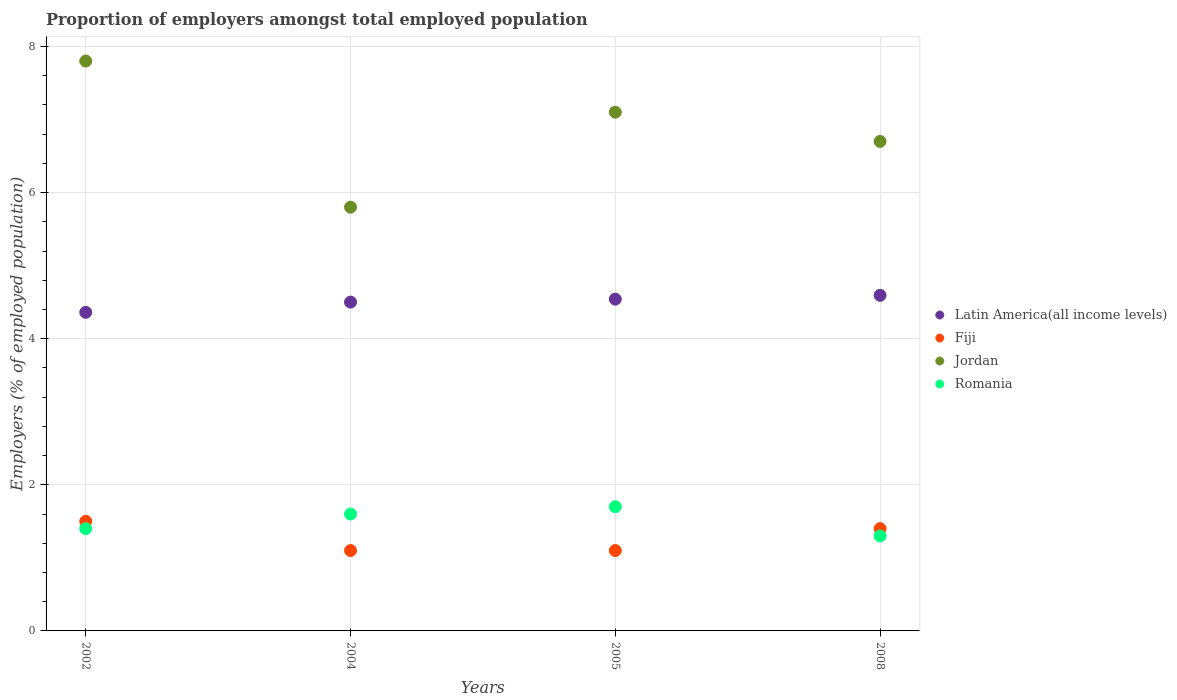What is the proportion of employers in Latin America(all income levels) in 2008?
Provide a short and direct response. 4.59. Across all years, what is the maximum proportion of employers in Romania?
Keep it short and to the point. 1.7. Across all years, what is the minimum proportion of employers in Romania?
Your answer should be compact. 1.3. In which year was the proportion of employers in Romania minimum?
Your answer should be compact. 2008. What is the total proportion of employers in Latin America(all income levels) in the graph?
Offer a terse response. 18. What is the difference between the proportion of employers in Latin America(all income levels) in 2004 and that in 2008?
Offer a very short reply. -0.09. What is the difference between the proportion of employers in Latin America(all income levels) in 2004 and the proportion of employers in Romania in 2005?
Your answer should be compact. 2.8. What is the average proportion of employers in Fiji per year?
Your response must be concise. 1.28. In the year 2002, what is the difference between the proportion of employers in Fiji and proportion of employers in Romania?
Provide a short and direct response. 0.1. In how many years, is the proportion of employers in Romania greater than 2 %?
Give a very brief answer. 0. What is the ratio of the proportion of employers in Latin America(all income levels) in 2002 to that in 2005?
Offer a terse response. 0.96. Is the difference between the proportion of employers in Fiji in 2002 and 2008 greater than the difference between the proportion of employers in Romania in 2002 and 2008?
Provide a succinct answer. No. What is the difference between the highest and the second highest proportion of employers in Latin America(all income levels)?
Keep it short and to the point. 0.05. What is the difference between the highest and the lowest proportion of employers in Jordan?
Keep it short and to the point. 2. Is it the case that in every year, the sum of the proportion of employers in Jordan and proportion of employers in Romania  is greater than the sum of proportion of employers in Latin America(all income levels) and proportion of employers in Fiji?
Your response must be concise. Yes. Does the proportion of employers in Latin America(all income levels) monotonically increase over the years?
Your answer should be compact. Yes. How many dotlines are there?
Make the answer very short. 4. Are the values on the major ticks of Y-axis written in scientific E-notation?
Provide a short and direct response. No. Where does the legend appear in the graph?
Give a very brief answer. Center right. How are the legend labels stacked?
Ensure brevity in your answer.  Vertical. What is the title of the graph?
Offer a very short reply. Proportion of employers amongst total employed population. Does "Suriname" appear as one of the legend labels in the graph?
Provide a short and direct response. No. What is the label or title of the X-axis?
Ensure brevity in your answer.  Years. What is the label or title of the Y-axis?
Your response must be concise. Employers (% of employed population). What is the Employers (% of employed population) of Latin America(all income levels) in 2002?
Provide a short and direct response. 4.36. What is the Employers (% of employed population) in Jordan in 2002?
Offer a very short reply. 7.8. What is the Employers (% of employed population) in Romania in 2002?
Provide a short and direct response. 1.4. What is the Employers (% of employed population) of Latin America(all income levels) in 2004?
Offer a very short reply. 4.5. What is the Employers (% of employed population) in Fiji in 2004?
Offer a terse response. 1.1. What is the Employers (% of employed population) of Jordan in 2004?
Your answer should be compact. 5.8. What is the Employers (% of employed population) in Romania in 2004?
Ensure brevity in your answer.  1.6. What is the Employers (% of employed population) in Latin America(all income levels) in 2005?
Provide a succinct answer. 4.54. What is the Employers (% of employed population) of Fiji in 2005?
Keep it short and to the point. 1.1. What is the Employers (% of employed population) in Jordan in 2005?
Provide a short and direct response. 7.1. What is the Employers (% of employed population) of Romania in 2005?
Ensure brevity in your answer.  1.7. What is the Employers (% of employed population) of Latin America(all income levels) in 2008?
Your response must be concise. 4.59. What is the Employers (% of employed population) in Fiji in 2008?
Offer a terse response. 1.4. What is the Employers (% of employed population) in Jordan in 2008?
Give a very brief answer. 6.7. What is the Employers (% of employed population) of Romania in 2008?
Offer a terse response. 1.3. Across all years, what is the maximum Employers (% of employed population) in Latin America(all income levels)?
Your answer should be compact. 4.59. Across all years, what is the maximum Employers (% of employed population) of Fiji?
Provide a succinct answer. 1.5. Across all years, what is the maximum Employers (% of employed population) of Jordan?
Make the answer very short. 7.8. Across all years, what is the maximum Employers (% of employed population) of Romania?
Provide a short and direct response. 1.7. Across all years, what is the minimum Employers (% of employed population) in Latin America(all income levels)?
Your answer should be compact. 4.36. Across all years, what is the minimum Employers (% of employed population) in Fiji?
Give a very brief answer. 1.1. Across all years, what is the minimum Employers (% of employed population) of Jordan?
Ensure brevity in your answer.  5.8. Across all years, what is the minimum Employers (% of employed population) of Romania?
Provide a short and direct response. 1.3. What is the total Employers (% of employed population) in Latin America(all income levels) in the graph?
Your response must be concise. 18. What is the total Employers (% of employed population) of Fiji in the graph?
Give a very brief answer. 5.1. What is the total Employers (% of employed population) in Jordan in the graph?
Make the answer very short. 27.4. What is the total Employers (% of employed population) in Romania in the graph?
Ensure brevity in your answer.  6. What is the difference between the Employers (% of employed population) of Latin America(all income levels) in 2002 and that in 2004?
Offer a terse response. -0.14. What is the difference between the Employers (% of employed population) of Fiji in 2002 and that in 2004?
Your answer should be compact. 0.4. What is the difference between the Employers (% of employed population) of Jordan in 2002 and that in 2004?
Your answer should be very brief. 2. What is the difference between the Employers (% of employed population) of Latin America(all income levels) in 2002 and that in 2005?
Keep it short and to the point. -0.18. What is the difference between the Employers (% of employed population) of Latin America(all income levels) in 2002 and that in 2008?
Your answer should be very brief. -0.23. What is the difference between the Employers (% of employed population) of Jordan in 2002 and that in 2008?
Make the answer very short. 1.1. What is the difference between the Employers (% of employed population) in Romania in 2002 and that in 2008?
Offer a very short reply. 0.1. What is the difference between the Employers (% of employed population) in Latin America(all income levels) in 2004 and that in 2005?
Make the answer very short. -0.04. What is the difference between the Employers (% of employed population) in Latin America(all income levels) in 2004 and that in 2008?
Your response must be concise. -0.09. What is the difference between the Employers (% of employed population) in Fiji in 2004 and that in 2008?
Your response must be concise. -0.3. What is the difference between the Employers (% of employed population) in Jordan in 2004 and that in 2008?
Your response must be concise. -0.9. What is the difference between the Employers (% of employed population) of Romania in 2004 and that in 2008?
Your response must be concise. 0.3. What is the difference between the Employers (% of employed population) of Latin America(all income levels) in 2005 and that in 2008?
Your answer should be very brief. -0.05. What is the difference between the Employers (% of employed population) in Jordan in 2005 and that in 2008?
Offer a terse response. 0.4. What is the difference between the Employers (% of employed population) of Romania in 2005 and that in 2008?
Your answer should be compact. 0.4. What is the difference between the Employers (% of employed population) in Latin America(all income levels) in 2002 and the Employers (% of employed population) in Fiji in 2004?
Keep it short and to the point. 3.26. What is the difference between the Employers (% of employed population) in Latin America(all income levels) in 2002 and the Employers (% of employed population) in Jordan in 2004?
Provide a succinct answer. -1.44. What is the difference between the Employers (% of employed population) of Latin America(all income levels) in 2002 and the Employers (% of employed population) of Romania in 2004?
Ensure brevity in your answer.  2.76. What is the difference between the Employers (% of employed population) in Fiji in 2002 and the Employers (% of employed population) in Jordan in 2004?
Ensure brevity in your answer.  -4.3. What is the difference between the Employers (% of employed population) in Fiji in 2002 and the Employers (% of employed population) in Romania in 2004?
Your answer should be compact. -0.1. What is the difference between the Employers (% of employed population) in Latin America(all income levels) in 2002 and the Employers (% of employed population) in Fiji in 2005?
Your answer should be compact. 3.26. What is the difference between the Employers (% of employed population) of Latin America(all income levels) in 2002 and the Employers (% of employed population) of Jordan in 2005?
Provide a short and direct response. -2.74. What is the difference between the Employers (% of employed population) of Latin America(all income levels) in 2002 and the Employers (% of employed population) of Romania in 2005?
Provide a short and direct response. 2.66. What is the difference between the Employers (% of employed population) of Fiji in 2002 and the Employers (% of employed population) of Romania in 2005?
Provide a succinct answer. -0.2. What is the difference between the Employers (% of employed population) in Jordan in 2002 and the Employers (% of employed population) in Romania in 2005?
Offer a very short reply. 6.1. What is the difference between the Employers (% of employed population) in Latin America(all income levels) in 2002 and the Employers (% of employed population) in Fiji in 2008?
Provide a succinct answer. 2.96. What is the difference between the Employers (% of employed population) in Latin America(all income levels) in 2002 and the Employers (% of employed population) in Jordan in 2008?
Ensure brevity in your answer.  -2.34. What is the difference between the Employers (% of employed population) in Latin America(all income levels) in 2002 and the Employers (% of employed population) in Romania in 2008?
Offer a terse response. 3.06. What is the difference between the Employers (% of employed population) in Fiji in 2002 and the Employers (% of employed population) in Romania in 2008?
Make the answer very short. 0.2. What is the difference between the Employers (% of employed population) in Latin America(all income levels) in 2004 and the Employers (% of employed population) in Fiji in 2005?
Give a very brief answer. 3.4. What is the difference between the Employers (% of employed population) of Latin America(all income levels) in 2004 and the Employers (% of employed population) of Jordan in 2005?
Give a very brief answer. -2.6. What is the difference between the Employers (% of employed population) in Latin America(all income levels) in 2004 and the Employers (% of employed population) in Romania in 2005?
Offer a very short reply. 2.8. What is the difference between the Employers (% of employed population) in Jordan in 2004 and the Employers (% of employed population) in Romania in 2005?
Make the answer very short. 4.1. What is the difference between the Employers (% of employed population) in Latin America(all income levels) in 2004 and the Employers (% of employed population) in Fiji in 2008?
Keep it short and to the point. 3.1. What is the difference between the Employers (% of employed population) of Latin America(all income levels) in 2004 and the Employers (% of employed population) of Jordan in 2008?
Ensure brevity in your answer.  -2.2. What is the difference between the Employers (% of employed population) in Latin America(all income levels) in 2004 and the Employers (% of employed population) in Romania in 2008?
Make the answer very short. 3.2. What is the difference between the Employers (% of employed population) in Fiji in 2004 and the Employers (% of employed population) in Jordan in 2008?
Make the answer very short. -5.6. What is the difference between the Employers (% of employed population) in Fiji in 2004 and the Employers (% of employed population) in Romania in 2008?
Provide a short and direct response. -0.2. What is the difference between the Employers (% of employed population) of Latin America(all income levels) in 2005 and the Employers (% of employed population) of Fiji in 2008?
Your response must be concise. 3.14. What is the difference between the Employers (% of employed population) of Latin America(all income levels) in 2005 and the Employers (% of employed population) of Jordan in 2008?
Give a very brief answer. -2.16. What is the difference between the Employers (% of employed population) of Latin America(all income levels) in 2005 and the Employers (% of employed population) of Romania in 2008?
Provide a succinct answer. 3.24. What is the difference between the Employers (% of employed population) in Fiji in 2005 and the Employers (% of employed population) in Jordan in 2008?
Provide a succinct answer. -5.6. What is the difference between the Employers (% of employed population) in Jordan in 2005 and the Employers (% of employed population) in Romania in 2008?
Offer a very short reply. 5.8. What is the average Employers (% of employed population) in Latin America(all income levels) per year?
Your answer should be compact. 4.5. What is the average Employers (% of employed population) in Fiji per year?
Make the answer very short. 1.27. What is the average Employers (% of employed population) of Jordan per year?
Offer a terse response. 6.85. What is the average Employers (% of employed population) in Romania per year?
Provide a succinct answer. 1.5. In the year 2002, what is the difference between the Employers (% of employed population) of Latin America(all income levels) and Employers (% of employed population) of Fiji?
Provide a succinct answer. 2.86. In the year 2002, what is the difference between the Employers (% of employed population) of Latin America(all income levels) and Employers (% of employed population) of Jordan?
Your response must be concise. -3.44. In the year 2002, what is the difference between the Employers (% of employed population) in Latin America(all income levels) and Employers (% of employed population) in Romania?
Your answer should be very brief. 2.96. In the year 2004, what is the difference between the Employers (% of employed population) in Latin America(all income levels) and Employers (% of employed population) in Fiji?
Give a very brief answer. 3.4. In the year 2004, what is the difference between the Employers (% of employed population) of Latin America(all income levels) and Employers (% of employed population) of Jordan?
Offer a terse response. -1.3. In the year 2004, what is the difference between the Employers (% of employed population) in Latin America(all income levels) and Employers (% of employed population) in Romania?
Offer a terse response. 2.9. In the year 2004, what is the difference between the Employers (% of employed population) in Fiji and Employers (% of employed population) in Jordan?
Your answer should be compact. -4.7. In the year 2004, what is the difference between the Employers (% of employed population) in Fiji and Employers (% of employed population) in Romania?
Keep it short and to the point. -0.5. In the year 2005, what is the difference between the Employers (% of employed population) in Latin America(all income levels) and Employers (% of employed population) in Fiji?
Your answer should be very brief. 3.44. In the year 2005, what is the difference between the Employers (% of employed population) in Latin America(all income levels) and Employers (% of employed population) in Jordan?
Your response must be concise. -2.56. In the year 2005, what is the difference between the Employers (% of employed population) in Latin America(all income levels) and Employers (% of employed population) in Romania?
Offer a very short reply. 2.84. In the year 2005, what is the difference between the Employers (% of employed population) in Jordan and Employers (% of employed population) in Romania?
Keep it short and to the point. 5.4. In the year 2008, what is the difference between the Employers (% of employed population) of Latin America(all income levels) and Employers (% of employed population) of Fiji?
Make the answer very short. 3.19. In the year 2008, what is the difference between the Employers (% of employed population) in Latin America(all income levels) and Employers (% of employed population) in Jordan?
Keep it short and to the point. -2.11. In the year 2008, what is the difference between the Employers (% of employed population) in Latin America(all income levels) and Employers (% of employed population) in Romania?
Keep it short and to the point. 3.29. In the year 2008, what is the difference between the Employers (% of employed population) of Fiji and Employers (% of employed population) of Jordan?
Your answer should be very brief. -5.3. What is the ratio of the Employers (% of employed population) in Latin America(all income levels) in 2002 to that in 2004?
Keep it short and to the point. 0.97. What is the ratio of the Employers (% of employed population) of Fiji in 2002 to that in 2004?
Your response must be concise. 1.36. What is the ratio of the Employers (% of employed population) of Jordan in 2002 to that in 2004?
Offer a terse response. 1.34. What is the ratio of the Employers (% of employed population) of Latin America(all income levels) in 2002 to that in 2005?
Give a very brief answer. 0.96. What is the ratio of the Employers (% of employed population) of Fiji in 2002 to that in 2005?
Provide a short and direct response. 1.36. What is the ratio of the Employers (% of employed population) in Jordan in 2002 to that in 2005?
Offer a terse response. 1.1. What is the ratio of the Employers (% of employed population) in Romania in 2002 to that in 2005?
Make the answer very short. 0.82. What is the ratio of the Employers (% of employed population) of Latin America(all income levels) in 2002 to that in 2008?
Keep it short and to the point. 0.95. What is the ratio of the Employers (% of employed population) in Fiji in 2002 to that in 2008?
Your answer should be very brief. 1.07. What is the ratio of the Employers (% of employed population) of Jordan in 2002 to that in 2008?
Your answer should be very brief. 1.16. What is the ratio of the Employers (% of employed population) in Romania in 2002 to that in 2008?
Make the answer very short. 1.08. What is the ratio of the Employers (% of employed population) in Latin America(all income levels) in 2004 to that in 2005?
Your answer should be very brief. 0.99. What is the ratio of the Employers (% of employed population) in Jordan in 2004 to that in 2005?
Make the answer very short. 0.82. What is the ratio of the Employers (% of employed population) of Latin America(all income levels) in 2004 to that in 2008?
Ensure brevity in your answer.  0.98. What is the ratio of the Employers (% of employed population) in Fiji in 2004 to that in 2008?
Your answer should be compact. 0.79. What is the ratio of the Employers (% of employed population) of Jordan in 2004 to that in 2008?
Provide a succinct answer. 0.87. What is the ratio of the Employers (% of employed population) of Romania in 2004 to that in 2008?
Offer a very short reply. 1.23. What is the ratio of the Employers (% of employed population) of Fiji in 2005 to that in 2008?
Provide a succinct answer. 0.79. What is the ratio of the Employers (% of employed population) in Jordan in 2005 to that in 2008?
Keep it short and to the point. 1.06. What is the ratio of the Employers (% of employed population) of Romania in 2005 to that in 2008?
Your answer should be very brief. 1.31. What is the difference between the highest and the second highest Employers (% of employed population) in Latin America(all income levels)?
Offer a terse response. 0.05. What is the difference between the highest and the lowest Employers (% of employed population) in Latin America(all income levels)?
Your answer should be very brief. 0.23. 